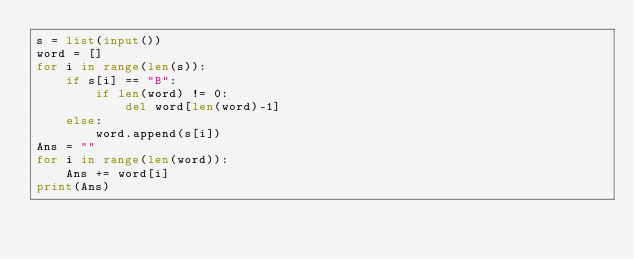Convert code to text. <code><loc_0><loc_0><loc_500><loc_500><_Python_>s = list(input())
word = []
for i in range(len(s)):
    if s[i] == "B":
        if len(word) != 0:
            del word[len(word)-1]
    else:
        word.append(s[i])
Ans = ""
for i in range(len(word)):
    Ans += word[i]
print(Ans)</code> 